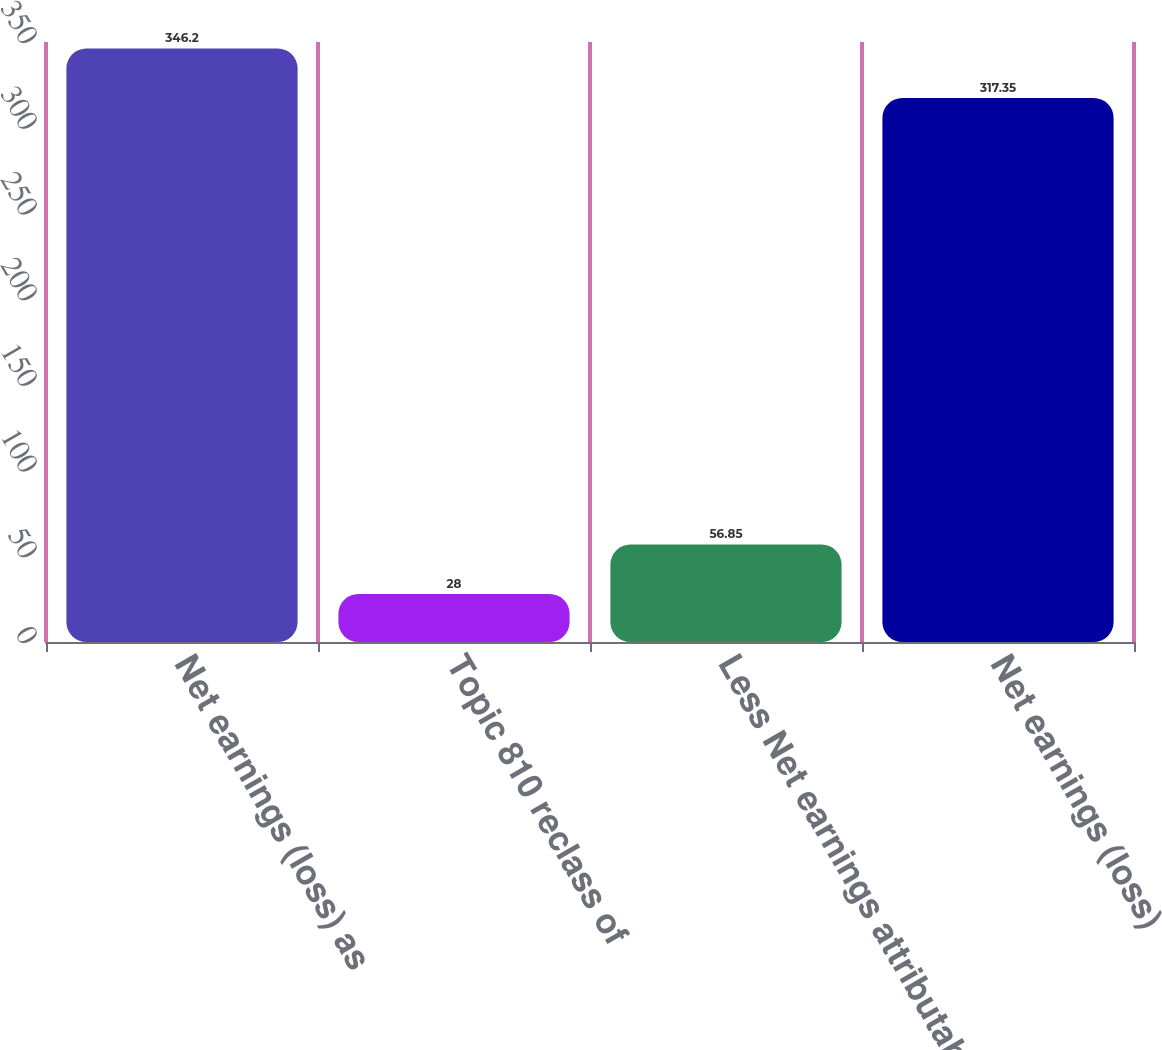<chart> <loc_0><loc_0><loc_500><loc_500><bar_chart><fcel>Net earnings (loss) as<fcel>Topic 810 reclass of<fcel>Less Net earnings attributable<fcel>Net earnings (loss)<nl><fcel>346.2<fcel>28<fcel>56.85<fcel>317.35<nl></chart> 